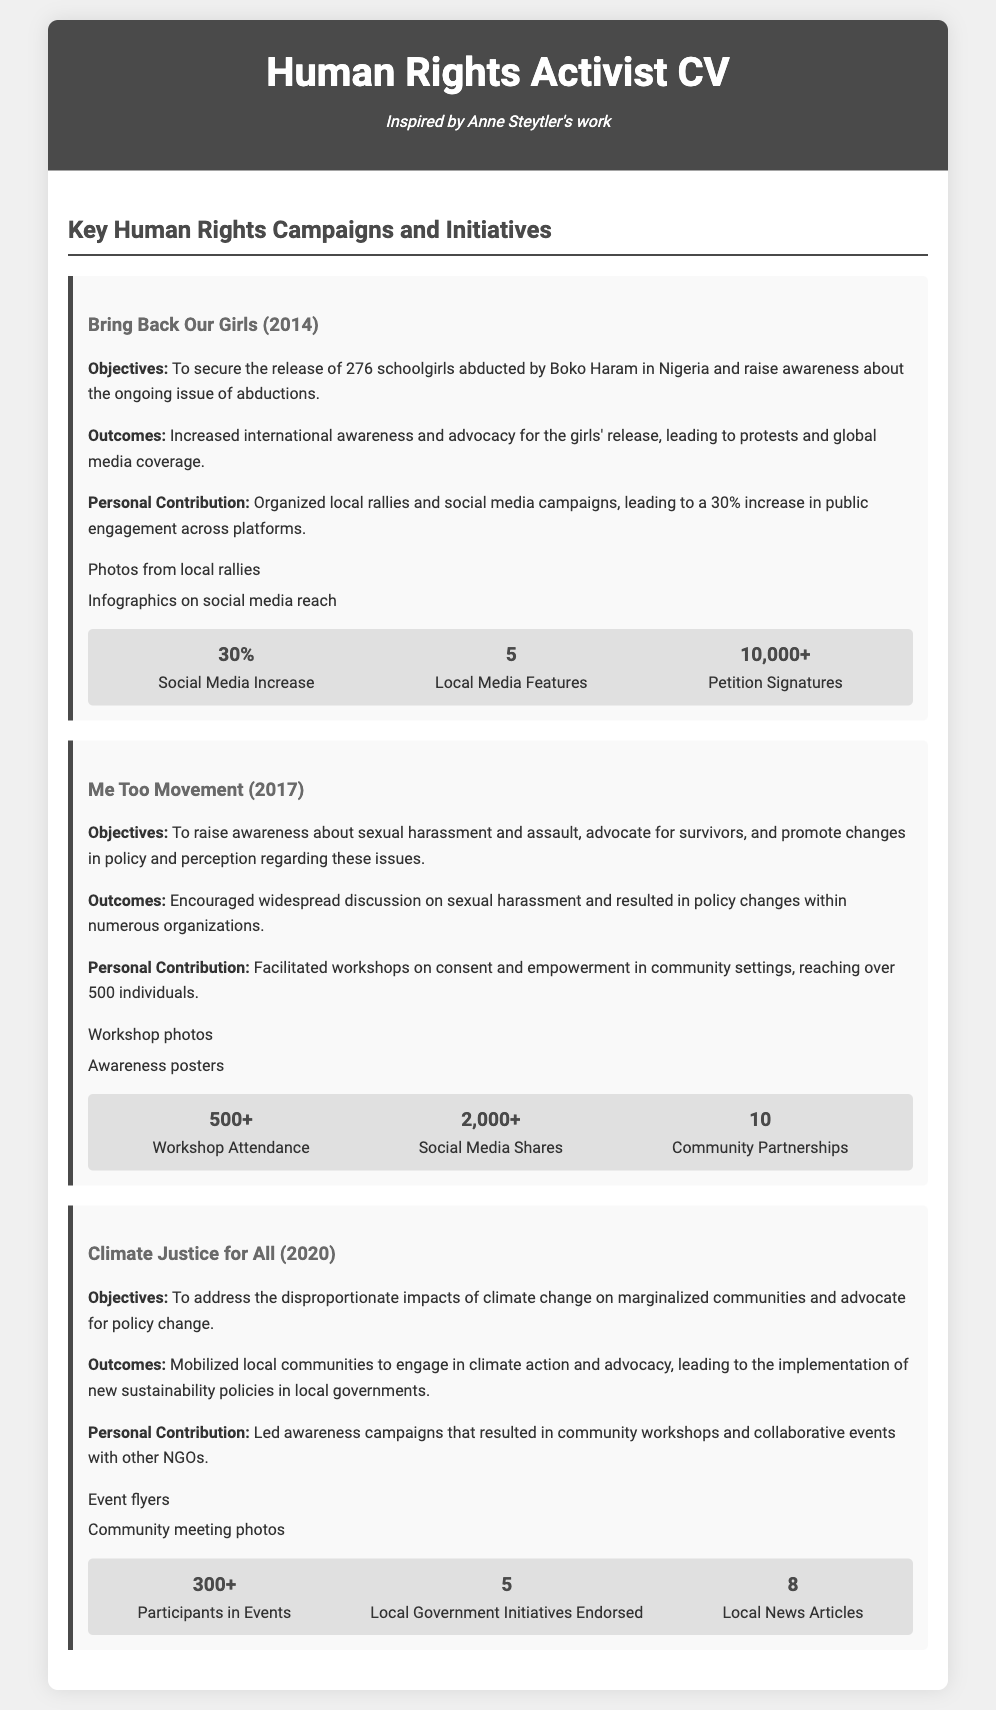What is the main objective of the Bring Back Our Girls campaign? The objective is to secure the release of 276 schoolgirls abducted by Boko Haram and raise awareness about abductions.
Answer: To secure the release of 276 schoolgirls What year was the Me Too Movement highlighted in the CV? The CV specifically mentions the Me Too Movement in 2017.
Answer: 2017 How many local media features were achieved during the Bring Back Our Girls campaign? The number of local media features mentioned in the document is 5.
Answer: 5 What was the outcome of the Climate Justice for All initiative? The outcome was the implementation of new sustainability policies in local governments.
Answer: Implementation of new sustainability policies How many participants attended the events under the Climate Justice for All initiative? The document states that there were 300+ participants in the events.
Answer: 300+ What type of contributions did the activist make to the Me Too Movement? The activist facilitated workshops on consent and empowerment in community settings.
Answer: Facilitated workshops on consent and empowerment Which campaign resulted in a 30% increase in public engagement across platforms? The Bring Back Our Girls campaign resulted in the 30% increase in public engagement.
Answer: Bring Back Our Girls How many local government initiatives were endorsed during the Climate Justice for All initiative? The document indicates that there were 5 local government initiatives endorsed.
Answer: 5 What personal contribution was made to the Bring Back Our Girls campaign? The activist organized local rallies and social media campaigns.
Answer: Organized local rallies and social media campaigns 